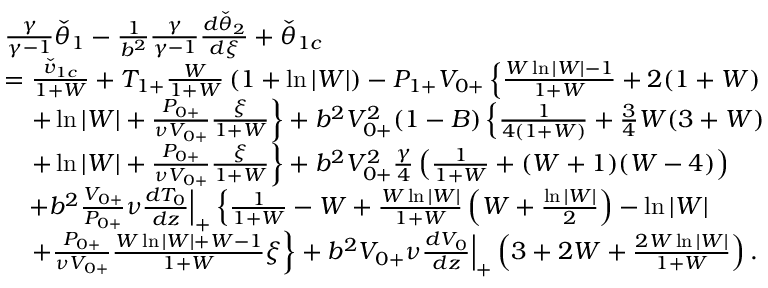<formula> <loc_0><loc_0><loc_500><loc_500>\begin{array} { r l } & { \frac { \gamma } { \gamma - 1 } \check { \theta } _ { 1 } - \frac { 1 } { b ^ { 2 } } \frac { \gamma } { \gamma - 1 } \frac { d \check { \theta } _ { 2 } } { d \xi } + \check { \theta } _ { 1 c } } \\ & { = \frac { \check { v } _ { 1 c } } { 1 + W } + T _ { 1 + } \frac { W } { 1 + W } \left ( 1 + \ln { | W | } \right ) - P _ { 1 + } V _ { 0 + } \left \{ \frac { W \ln { | W | } - 1 } { 1 + W } + 2 ( 1 + W ) } \\ & { \quad + \ln { | W | } + \frac { P _ { 0 + } } { \nu V _ { 0 + } } \frac { \xi } { 1 + W } \right \} + b ^ { 2 } V _ { 0 + } ^ { 2 } ( 1 - B ) \left \{ \frac { 1 } { 4 ( 1 + W ) } + \frac { 3 } { 4 } W ( 3 + W ) } \\ & { \quad + \ln { | W | } + \frac { P _ { 0 + } } { \nu V _ { 0 + } } \frac { \xi } { 1 + W } \right \} + b ^ { 2 } V _ { 0 + } ^ { 2 } \frac { \gamma } { 4 } \left ( \frac { 1 } { 1 + W } + ( W + 1 ) ( W - 4 ) \right ) } \\ & { \quad + b ^ { 2 } \frac { V _ { 0 + } } { P _ { 0 + } } \nu \frac { d T _ { 0 } } { d z } \left | _ { + } \left \{ \frac { 1 } { 1 + W } - W + \frac { W \ln { | W | } } { 1 + W } \left ( W + \frac { \ln { | W | } } { 2 } \right ) - \ln { | W | } } \\ & { \quad + \frac { P _ { 0 + } } { \nu V _ { 0 + } } \frac { W \ln { | W | } + W - 1 } { 1 + W } \xi \right \} + b ^ { 2 } V _ { 0 + } \nu \frac { d V _ { 0 } } { d z } \right | _ { + } \left ( 3 + 2 W + \frac { 2 W \ln { | W | } } { 1 + W } \right ) . } \end{array}</formula> 